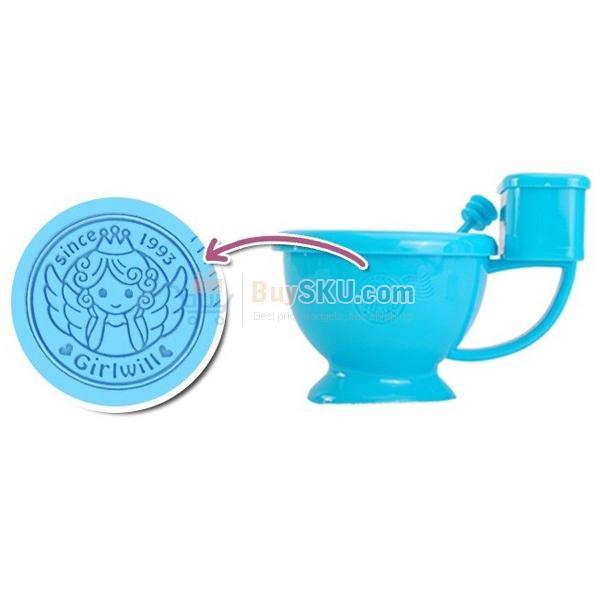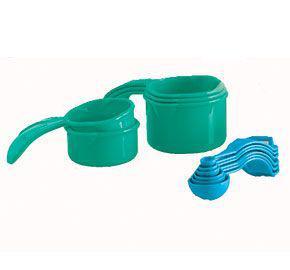The first image is the image on the left, the second image is the image on the right. Analyze the images presented: Is the assertion "An image includes a royal blue container with a white stripe and white spoon." valid? Answer yes or no. No. 